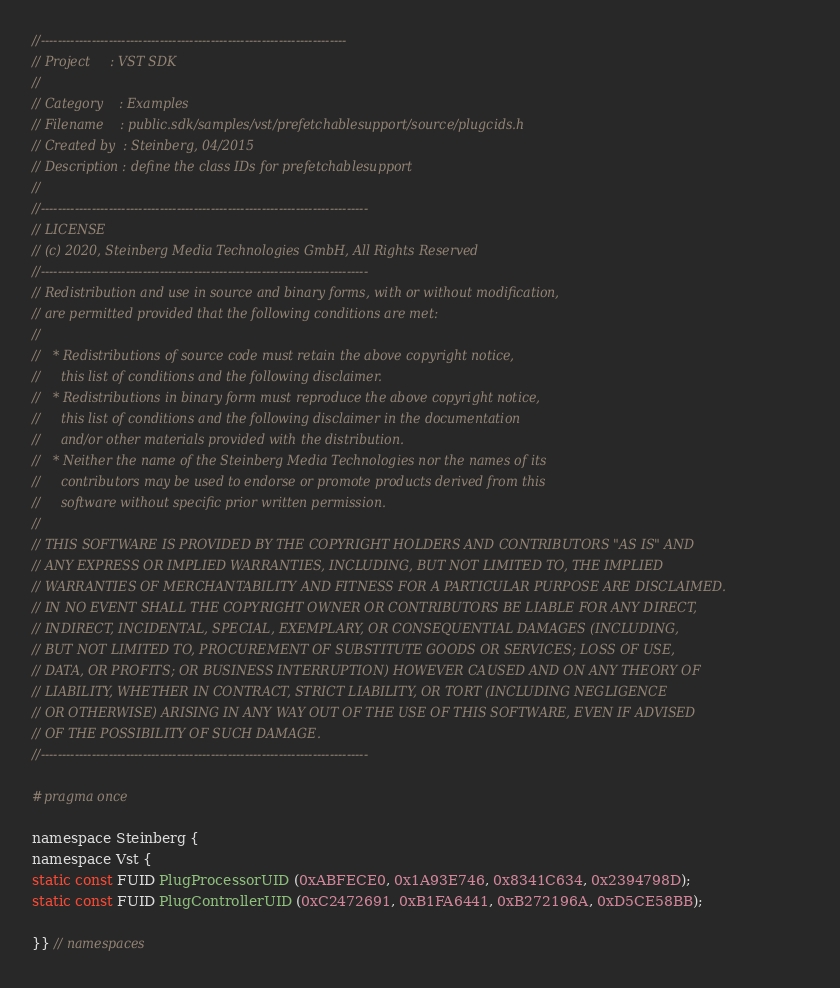<code> <loc_0><loc_0><loc_500><loc_500><_C_>//------------------------------------------------------------------------
// Project     : VST SDK
//
// Category    : Examples
// Filename    : public.sdk/samples/vst/prefetchablesupport/source/plugcids.h
// Created by  : Steinberg, 04/2015
// Description : define the class IDs for prefetchablesupport
//
//-----------------------------------------------------------------------------
// LICENSE
// (c) 2020, Steinberg Media Technologies GmbH, All Rights Reserved
//-----------------------------------------------------------------------------
// Redistribution and use in source and binary forms, with or without modification,
// are permitted provided that the following conditions are met:
// 
//   * Redistributions of source code must retain the above copyright notice, 
//     this list of conditions and the following disclaimer.
//   * Redistributions in binary form must reproduce the above copyright notice,
//     this list of conditions and the following disclaimer in the documentation 
//     and/or other materials provided with the distribution.
//   * Neither the name of the Steinberg Media Technologies nor the names of its
//     contributors may be used to endorse or promote products derived from this 
//     software without specific prior written permission.
// 
// THIS SOFTWARE IS PROVIDED BY THE COPYRIGHT HOLDERS AND CONTRIBUTORS "AS IS" AND
// ANY EXPRESS OR IMPLIED WARRANTIES, INCLUDING, BUT NOT LIMITED TO, THE IMPLIED 
// WARRANTIES OF MERCHANTABILITY AND FITNESS FOR A PARTICULAR PURPOSE ARE DISCLAIMED. 
// IN NO EVENT SHALL THE COPYRIGHT OWNER OR CONTRIBUTORS BE LIABLE FOR ANY DIRECT, 
// INDIRECT, INCIDENTAL, SPECIAL, EXEMPLARY, OR CONSEQUENTIAL DAMAGES (INCLUDING, 
// BUT NOT LIMITED TO, PROCUREMENT OF SUBSTITUTE GOODS OR SERVICES; LOSS OF USE, 
// DATA, OR PROFITS; OR BUSINESS INTERRUPTION) HOWEVER CAUSED AND ON ANY THEORY OF 
// LIABILITY, WHETHER IN CONTRACT, STRICT LIABILITY, OR TORT (INCLUDING NEGLIGENCE 
// OR OTHERWISE) ARISING IN ANY WAY OUT OF THE USE OF THIS SOFTWARE, EVEN IF ADVISED
// OF THE POSSIBILITY OF SUCH DAMAGE.
//-----------------------------------------------------------------------------

#pragma once

namespace Steinberg {
namespace Vst {
static const FUID PlugProcessorUID (0xABFECE0, 0x1A93E746, 0x8341C634, 0x2394798D);
static const FUID PlugControllerUID (0xC2472691, 0xB1FA6441, 0xB272196A, 0xD5CE58BB);

}} // namespaces
</code> 